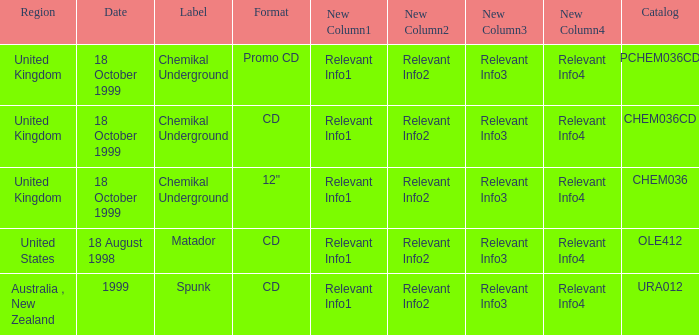What date is associated with the Spunk label? 1999.0. 